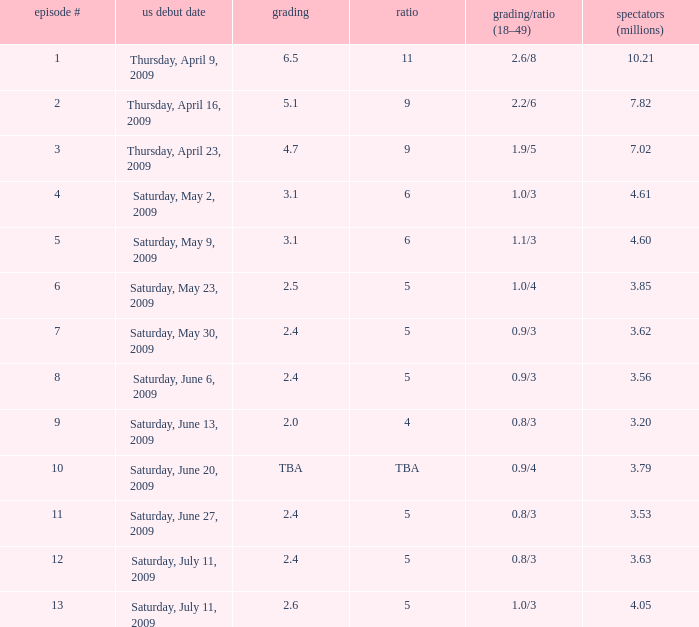What is the lowest number of million viewers for an episode before episode 5 with a rating/share of 1.1/3? None. 